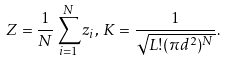Convert formula to latex. <formula><loc_0><loc_0><loc_500><loc_500>Z = \frac { 1 } { N } \sum _ { i = 1 } ^ { N } z _ { i } , \, K = \frac { 1 } { \sqrt { L ! ( \pi d ^ { 2 } ) ^ { N } } } .</formula> 